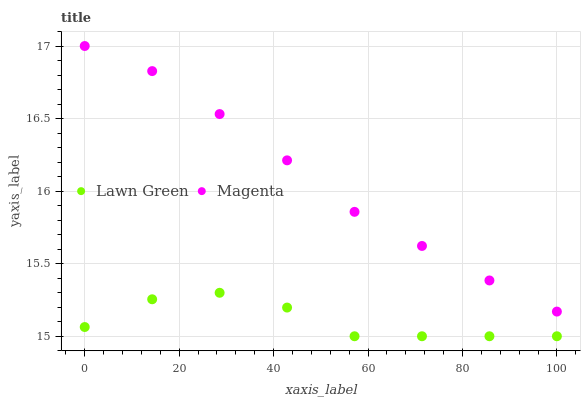Does Lawn Green have the minimum area under the curve?
Answer yes or no. Yes. Does Magenta have the maximum area under the curve?
Answer yes or no. Yes. Does Magenta have the minimum area under the curve?
Answer yes or no. No. Is Magenta the smoothest?
Answer yes or no. Yes. Is Lawn Green the roughest?
Answer yes or no. Yes. Is Magenta the roughest?
Answer yes or no. No. Does Lawn Green have the lowest value?
Answer yes or no. Yes. Does Magenta have the lowest value?
Answer yes or no. No. Does Magenta have the highest value?
Answer yes or no. Yes. Is Lawn Green less than Magenta?
Answer yes or no. Yes. Is Magenta greater than Lawn Green?
Answer yes or no. Yes. Does Lawn Green intersect Magenta?
Answer yes or no. No. 